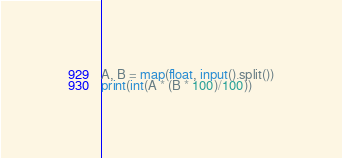Convert code to text. <code><loc_0><loc_0><loc_500><loc_500><_Python_>A, B = map(float, input().split())
print(int(A * (B * 100)/100))</code> 